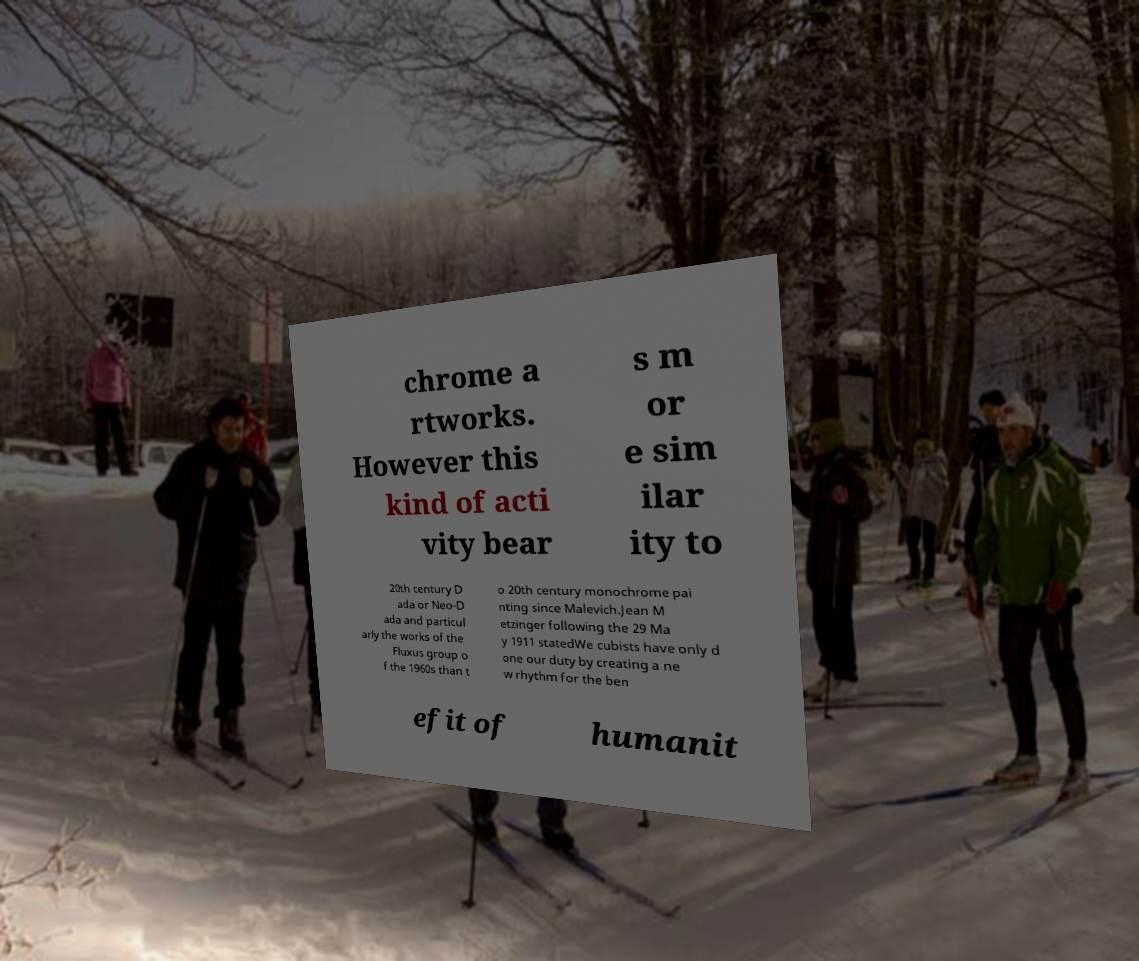Please read and relay the text visible in this image. What does it say? chrome a rtworks. However this kind of acti vity bear s m or e sim ilar ity to 20th century D ada or Neo-D ada and particul arly the works of the Fluxus group o f the 1960s than t o 20th century monochrome pai nting since Malevich.Jean M etzinger following the 29 Ma y 1911 statedWe cubists have only d one our duty by creating a ne w rhythm for the ben efit of humanit 